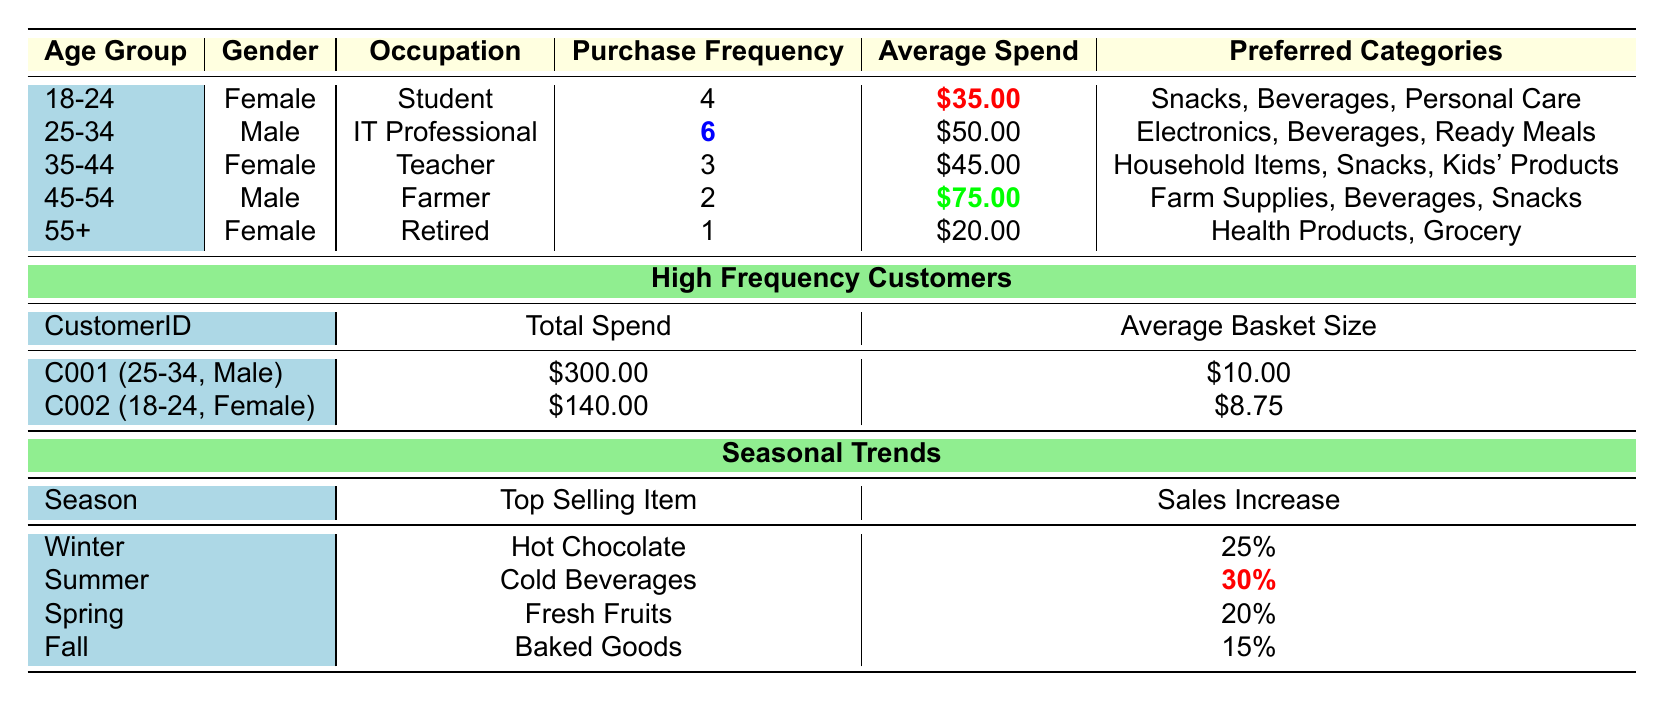What is the average spend for the 45-54 age group? The average spend for the 45-54 age group is highlighted in the table as \$75.00.
Answer: \$75.00 Which gender has higher average spend in the demographic data? The average spend for males (45-54 age group) is \$75.00, while females have an average spend of \$35.00 (18-24 age group) and \$45.00 (35-44 age group). The highest is \$75.00 for males.
Answer: Male How many customers fall into the 55+ age group, and how much do they spend on average? There is one customer in the 55+ age group with an average spend of \$20.00.
Answer: 1 customer, \$20.00 What is the total spend of high frequency customer C001? High frequency customer C001's total spend is highlighted in the table as \$300.00.
Answer: \$300.00 Which season has the highest sales increase percentage, and what is that percentage? The summer season shows a highlighted sales increase percentage of 30%, which is the highest among all seasons listed.
Answer: 30% How does the average spend for students compare to farmers? The average spend for students (18-24 age group) is \$35.00, while for farmers (45-54 age group) it is \$75.00. The difference is \$75.00 - \$35.00 = \$40.00, indicating farmers spend more.
Answer: Farmers spend \$40.00 more Are there no retired females who spend more than \$25.00 on average? The retired female has an average spend of \$20.00, which is less than \$25.00, confirming the statement as true.
Answer: True If you combine the purchase frequency of the 25-34 and 35-44 age groups, what will it total? The purchase frequency for the 25-34 age group is 6, and for the 35-44 age group, it is 3. Adding these gives 6 + 3 = 9.
Answer: 9 Which gender has the highest average basket size among high frequency customers? Customer C001 (Male) has an average basket size of \$10.00, while customer C002 (Female) has \$8.75. The higher is \$10.00 for males.
Answer: Male What is the most popular item sold in winter and its sales increase percentage? The top-selling item in winter is Hot Chocolate with a sales increase of 25%.
Answer: Hot Chocolate, 25% 